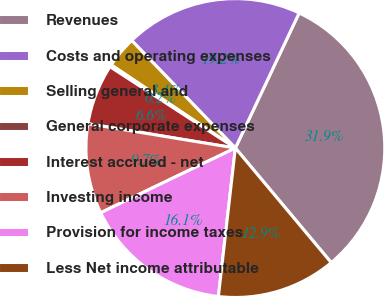Convert chart. <chart><loc_0><loc_0><loc_500><loc_500><pie_chart><fcel>Revenues<fcel>Costs and operating expenses<fcel>Selling general and<fcel>General corporate expenses<fcel>Interest accrued - net<fcel>Investing income<fcel>Provision for income taxes<fcel>Less Net income attributable<nl><fcel>31.89%<fcel>19.23%<fcel>3.4%<fcel>0.23%<fcel>6.56%<fcel>9.73%<fcel>16.06%<fcel>12.9%<nl></chart> 